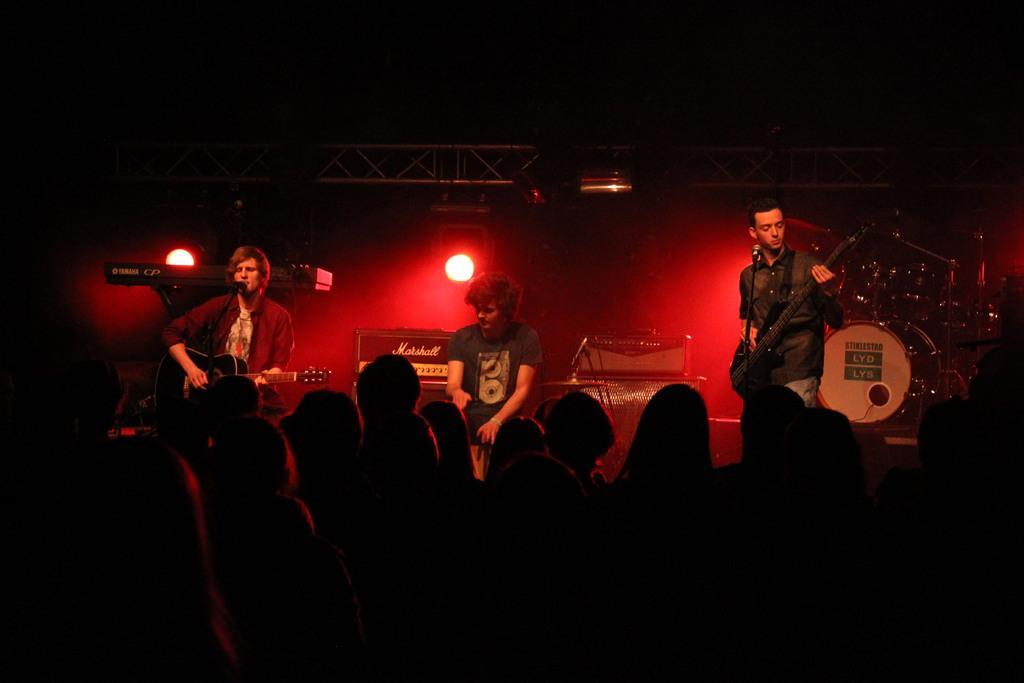How would you summarize this image in a sentence or two? In this picture there is a man who is sitting on the table, beside him there are two persons who are playing a guitar and standing in front of the mic. Backside of them I can see the musical instruments and focus lights. At the bottom I can see the audience who are standing near to the stage. At the top I can see the darkness. 